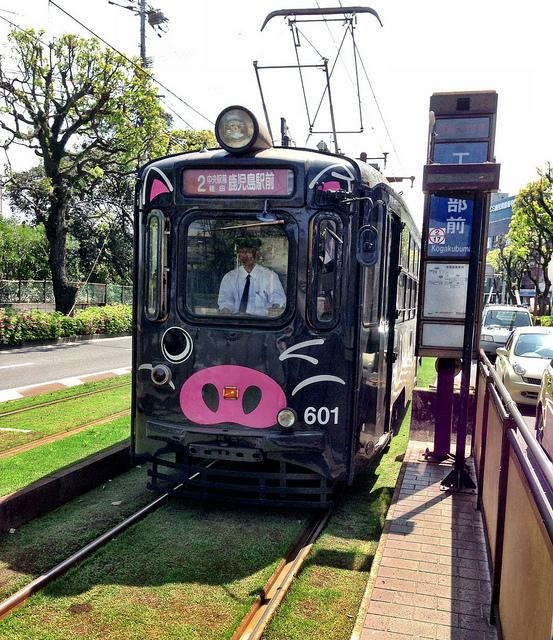How is the trolley powered? Please explain your reasoning. electricity. The apparatus on top of the trolley draws power from an electric wire, which powers the car's electric motor. 